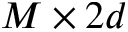<formula> <loc_0><loc_0><loc_500><loc_500>M \times 2 d</formula> 